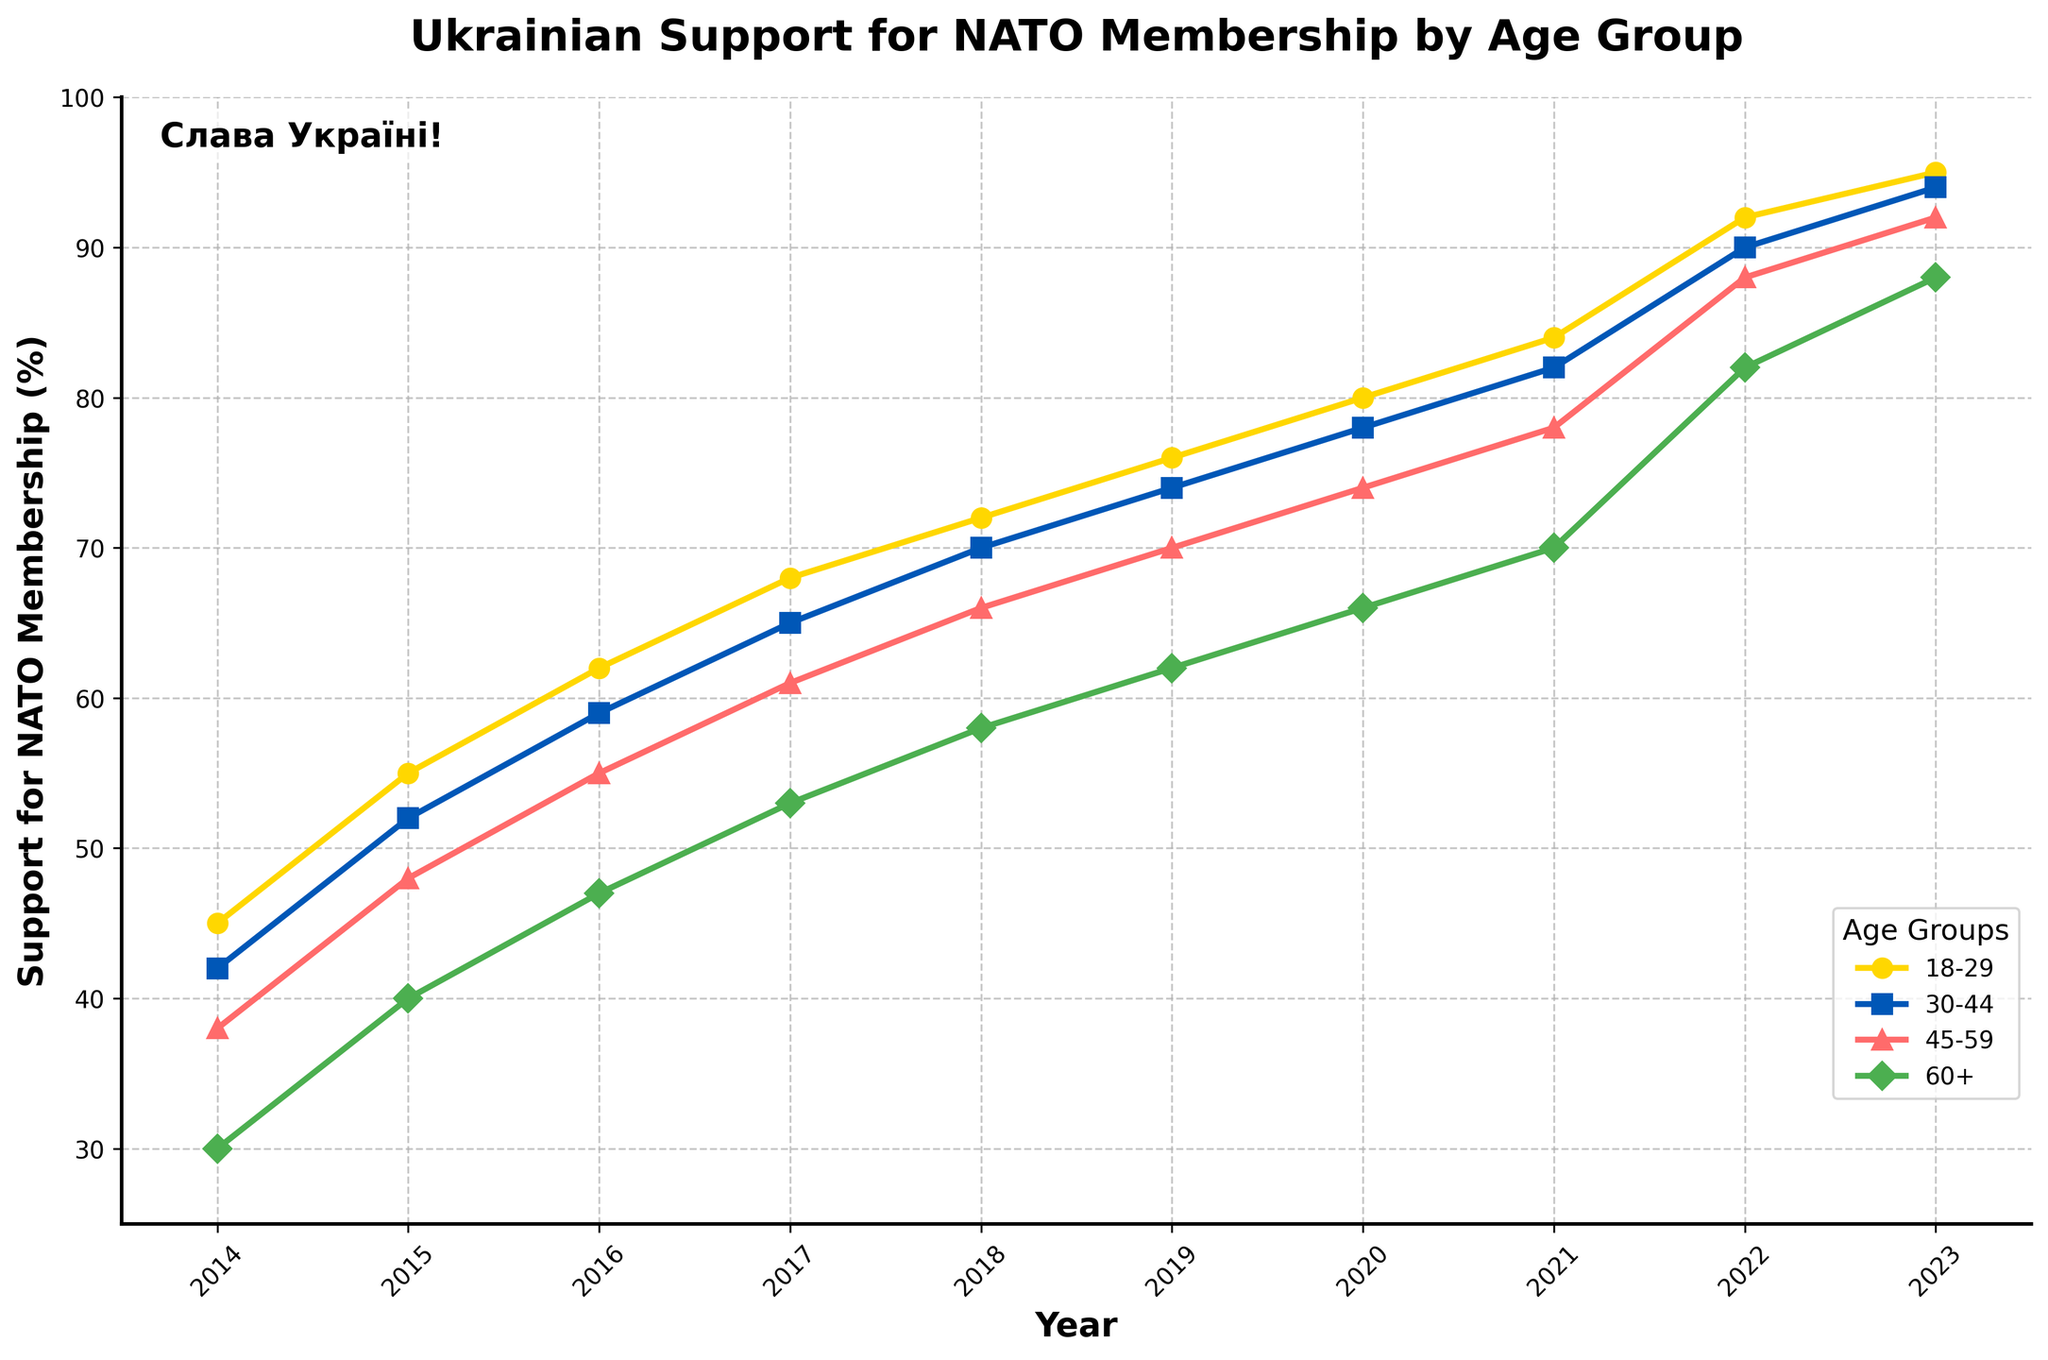What was the support for NATO membership among the 18-29 age group in 2018? Locate the 18-29 age group line and find the point corresponding to 2018. The y-axis value gives the support percentage, which is 72%.
Answer: 72% Which age group showed the highest support for NATO membership in 2023? Compare the y-axis values for all age groups in 2023. The 18-29 age group's value is the highest at 95%.
Answer: 18-29 How did the support for NATO membership among the 45-59 age group change from 2014 to 2022? Find the y-axis values for 45-59 age group in 2014 (38%) and 2022 (88%). The difference in support is 88% - 38% = 50%.
Answer: Increased by 50% In which year did the 30-44 age group surpass 80% support for NATO membership? Trace the 30-44 age group's line and identify the year when the y-axis value first exceeds 80%. This happens in 2021.
Answer: 2021 What is the average support for NATO membership across all age groups in 2015? Find the 2015 support values for each age group: 18-29 (55%), 30-44 (52%), 45-59 (48%), 60+ (40%). Average = (55 + 52 + 48 + 40) / 4 = 48.75%.
Answer: 48.75% By how much did support for NATO membership among the 60+ age group increase from 2017 to 2023? Support in 2017 is 53%, and in 2023 it is 88%. The increase is 88% - 53% = 35%.
Answer: Increased by 35% Which age group had the lowest growth in support for NATO membership from 2014 to 2023? Calculate the change for each age group: 18-29 (95-45=50%), 30-44 (94-42=52%), 45-59 (92-38=54%), 60+ (88-30=58%). The 18-29 age group had the lowest growth with 50%.
Answer: 18-29 Between which consecutive years did the 18-29 age group see the largest increase in NATO membership support? Examine the year-to-year differences in the 18-29 age group's support: 2014-2015 (10%), 2015-2016 (7%), 2016-2017 (6%), 2017-2018 (4%), 2018-2019 (4%), 2019-2020 (4%), 2020-2021 (4%), 2021-2022 (8%), 2022-2023 (3%). The largest increase is between 2014-2015 (10%).
Answer: 2014-2015 Compare the relative positions of all age group lines in 2020. Which visual attribute can help to distinguish the 60+ age group? In 2020, the 60+ age group has the lowest y-axis value compared to other age groups. The 60+ line is marked with a green color and a 'D' shaped marker, which are unique features.
Answer: Green color and 'D' marker What is the median support value among the age groups in 2022? Arrange the 2022 support values: 18-29 (92%), 30-44 (90%), 45-59 (88%), 60+ (82%). The median is the average of the two middle values (90% and 88%). (90 + 88) / 2 = 89%.
Answer: 89% 